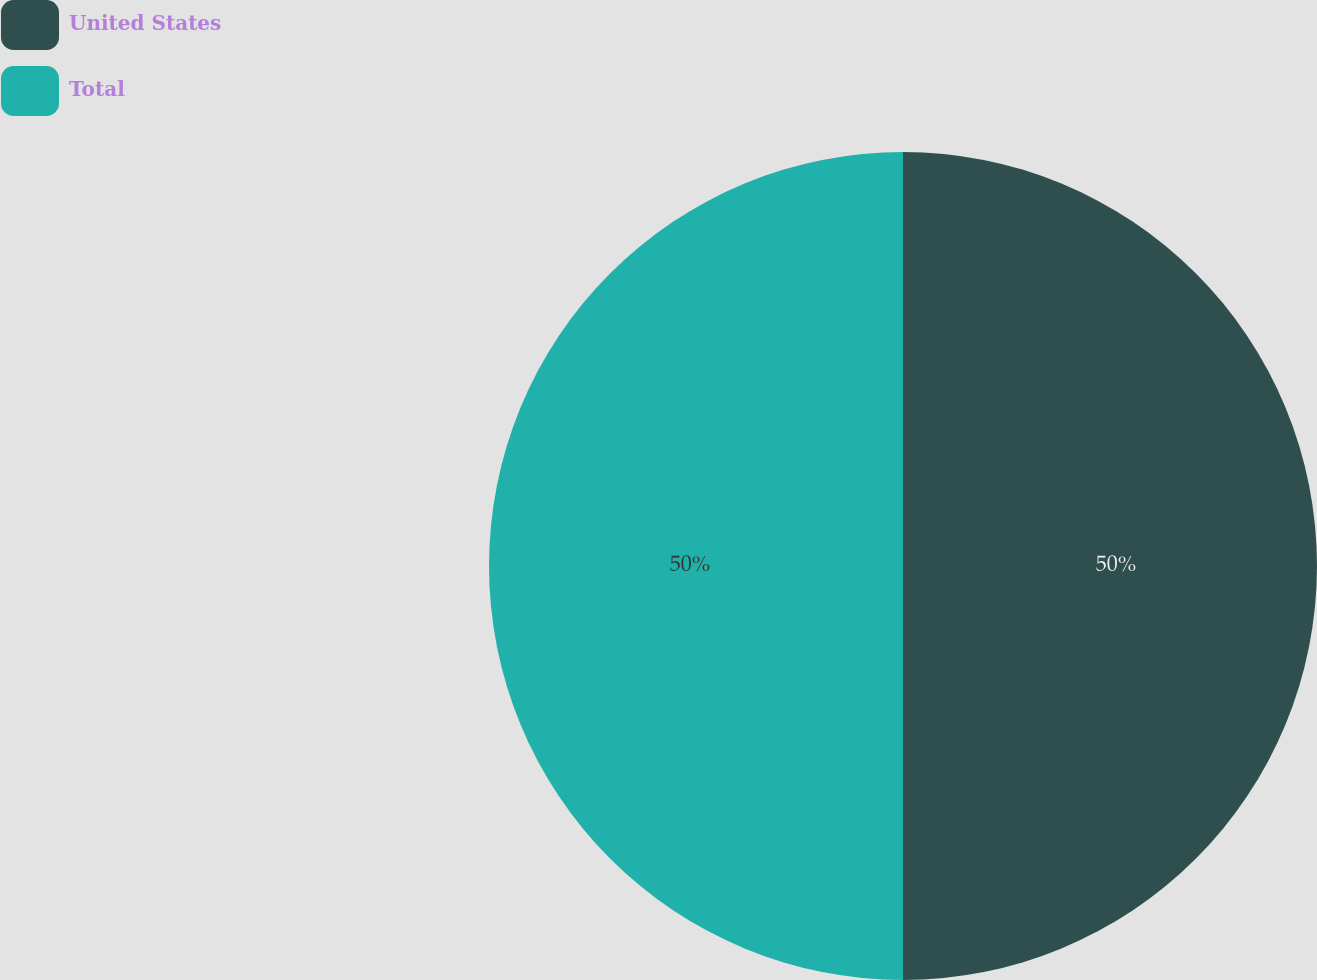<chart> <loc_0><loc_0><loc_500><loc_500><pie_chart><fcel>United States<fcel>Total<nl><fcel>50.0%<fcel>50.0%<nl></chart> 